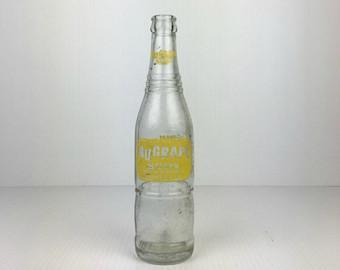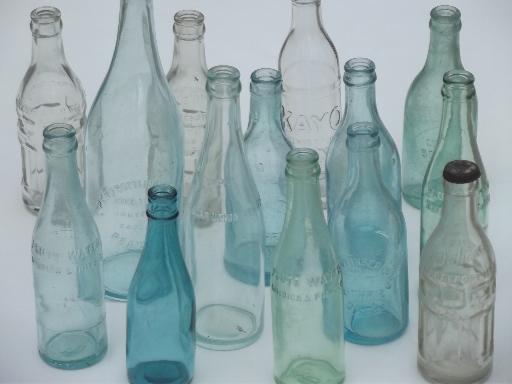The first image is the image on the left, the second image is the image on the right. Evaluate the accuracy of this statement regarding the images: "The right image contains exactly one glass bottle.". Is it true? Answer yes or no. No. The first image is the image on the left, the second image is the image on the right. For the images shown, is this caption "One image shows a single upright, uncapped clear bottle with a colored label and ridges around the glass, and the other image shows at least six varied glass bottles without colored labels." true? Answer yes or no. Yes. 